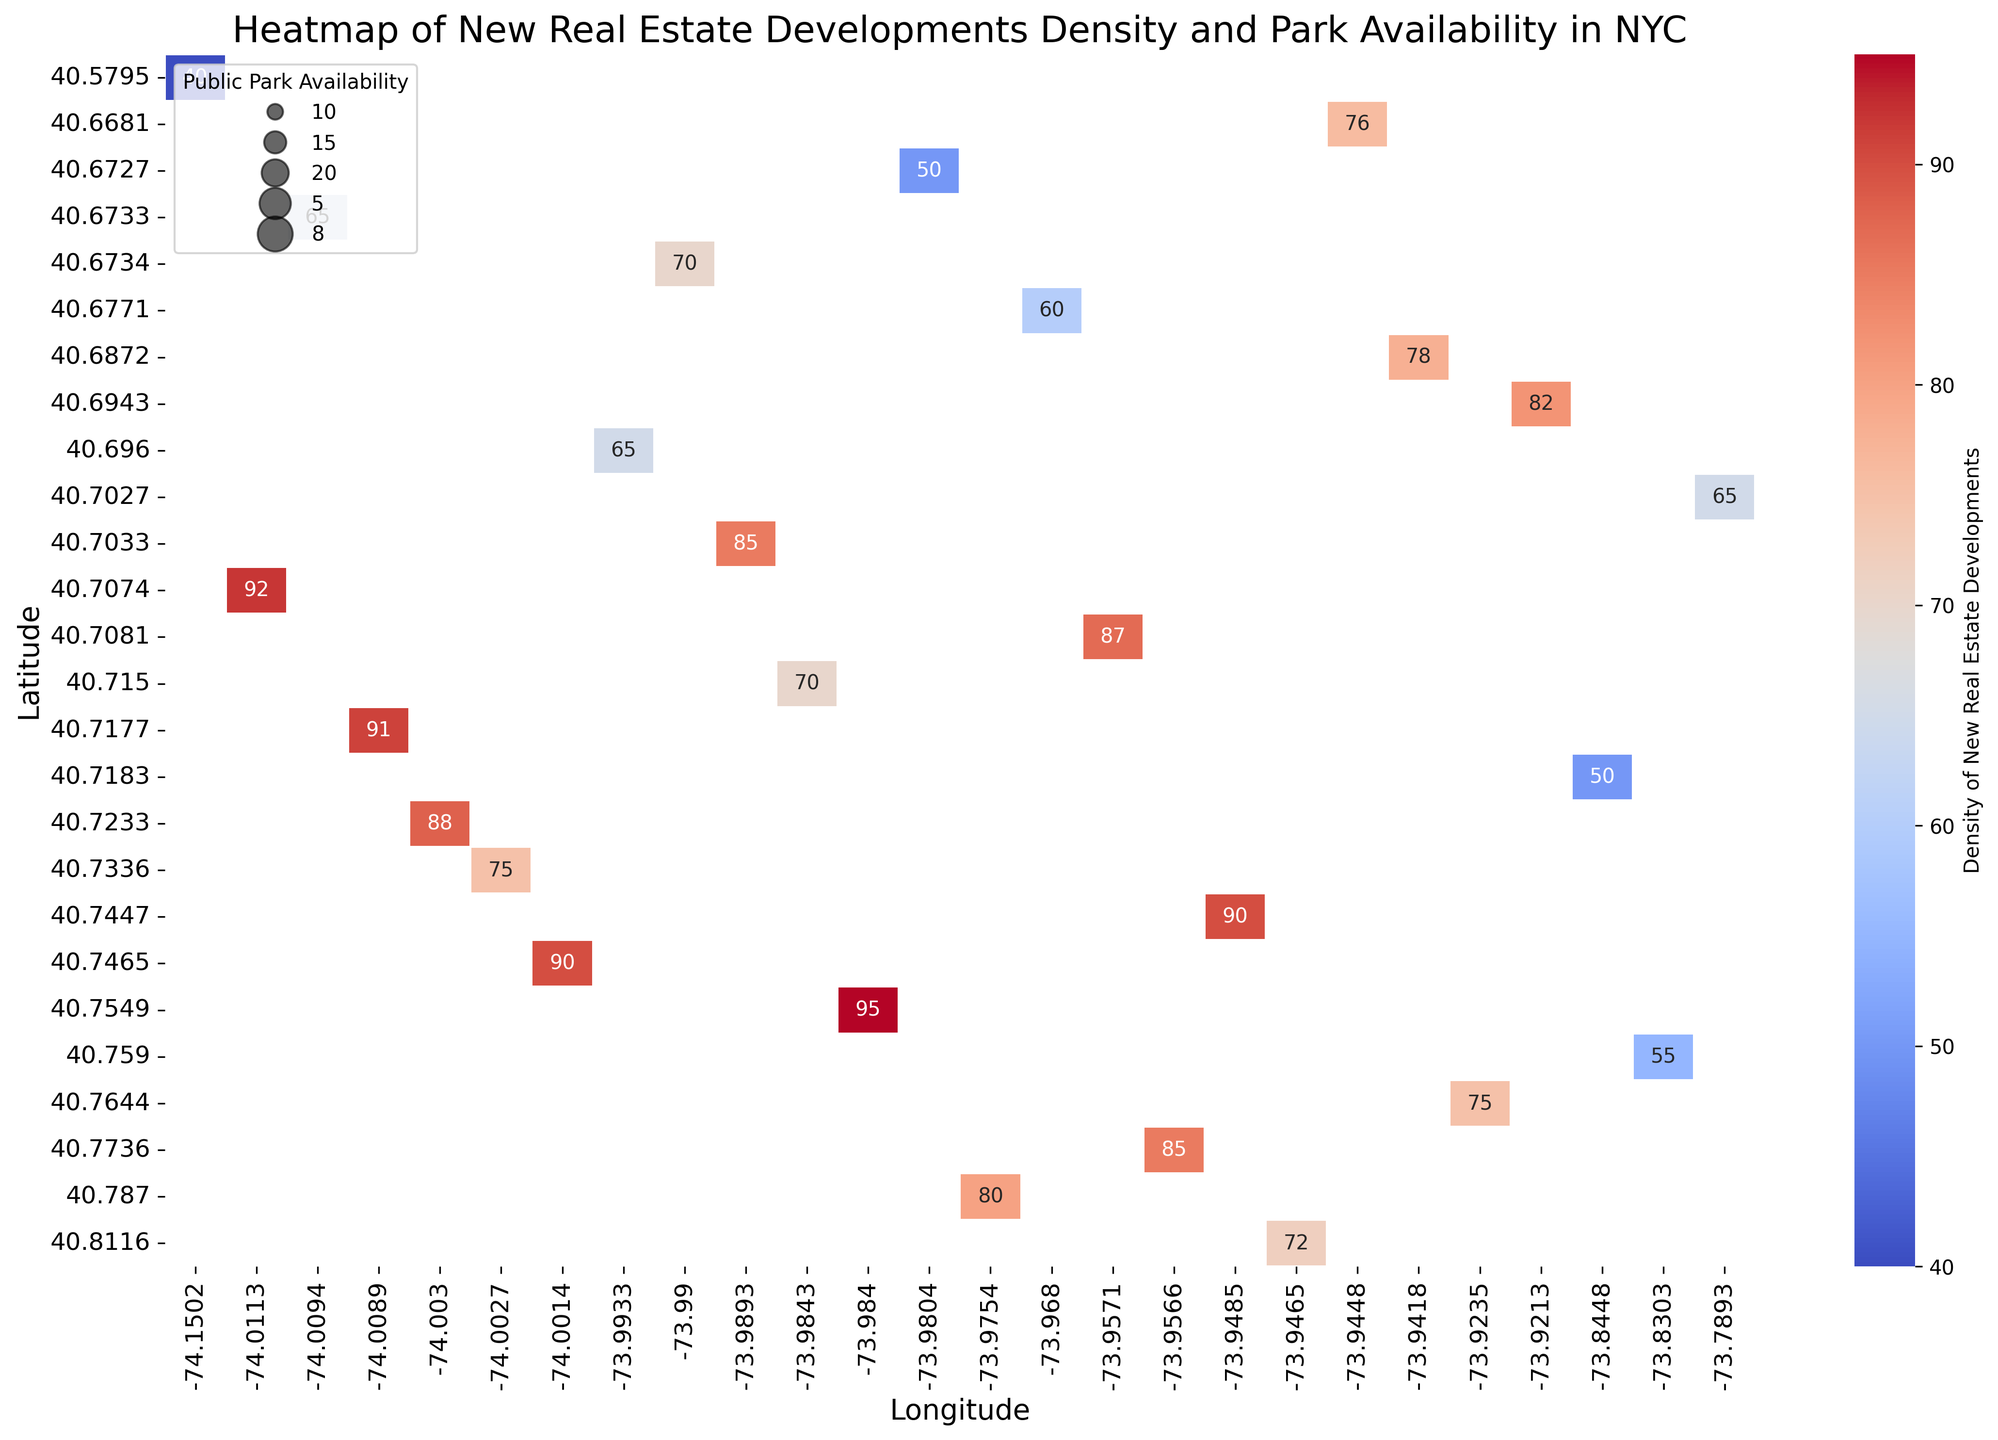What neighborhood has the highest density of new real estate developments? In the heatmap, the Financial District has the darkest red color, indicating the highest density of new real estate developments.
Answer: Financial District Which neighborhood has the lowest public park availability? By checking the size of the black dots, which represent public park availability, the smallest dot is in Midtown, indicating the lowest availability.
Answer: Midtown Compare the neighborhoods of Williamsburg and Chelsea in terms of public park availability. Which one has more? The size of the dots in Williamsburg and Chelsea are compared. Williamsburg has a slightly larger dot indicating more availability.
Answer: Williamsburg What relationship do you observe between the density of new real estate developments and public park availability? By examining the figure, it generally shows that areas with higher real estate density have lower public park availability, as there are darker red regions with smaller black dots.
Answer: Inverse relationship Which neighborhoods have a density of new real estate developments between 80 and 90? Checking the color of cells in the heatmap, Upper West Side, Soho, Tribeca and Williamsburg all fall within a medium red shade corresponding to densities between 80 and 90.
Answer: Upper West Side, Soho, Tribeca, Williamsburg What is the difference in density of new real estate developments between Harlem and Midtown? Harlem has a density of 72 while Midtown has a density of 95. The difference is 95 - 72 = 23.
Answer: 23 How does public park availability in DUMBO compare to Park Slope? The size of the dots shows that Park Slope has a dot significantly larger than DUMBO’s, indicating much higher park availability.
Answer: Park Slope Are there any neighborhoods with high-density new real estate developments and high public park availability? By checking the heatmap and the size of the dots, no neighborhoods have both high-density (dark red) and large dot size.
Answer: No What is the combined density of new real estate developments of Bushwick, DUMBO, and Crown Heights? Adding the densities: Bushwick (82), DUMBO (85), Crown Heights (76). Total 82 + 85 + 76 = 243.
Answer: 243 